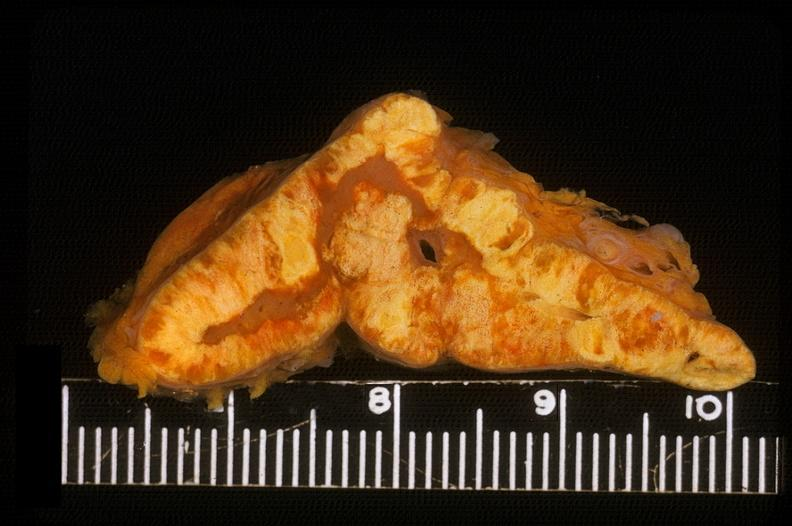s endocrine present?
Answer the question using a single word or phrase. Yes 